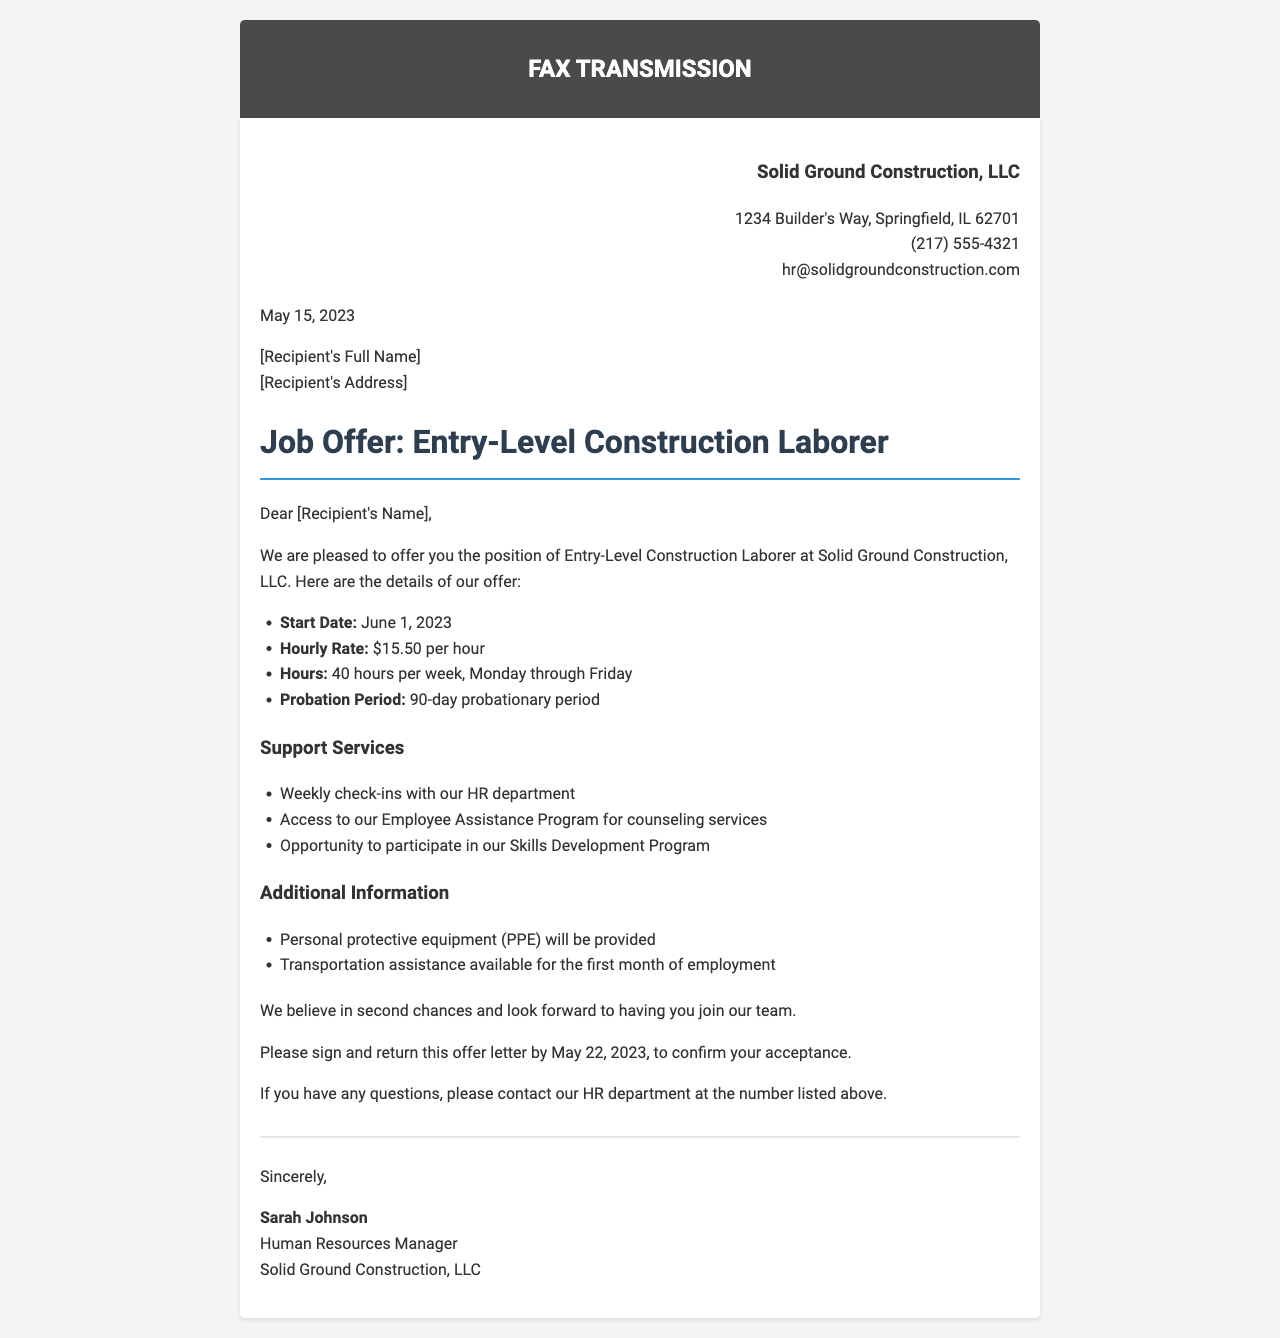What is the name of the company? The company is Solid Ground Construction, LLC, as stated in the document's header.
Answer: Solid Ground Construction, LLC What is the position offered? The job offer specifies the position as Entry-Level Construction Laborer.
Answer: Entry-Level Construction Laborer What is the hourly rate for the position? The document indicates the hourly rate to be $15.50 per hour.
Answer: $15.50 per hour When does the probation period end? The probationary period is stated to be 90 days, which concludes after the start date of June 1, 2023.
Answer: August 30, 2023 What support service offers weekly check-ins? The HR department will provide weekly check-ins as part of their support services.
Answer: HR department Is transportation assistance available? The document mentions that transportation assistance is available for the first month of employment.
Answer: Yes What is the deadline to return the offer letter? The letter specifies the deadline to return it as May 22, 2023.
Answer: May 22, 2023 Who is the Human Resources Manager? The signature section identifies Sarah Johnson as the Human Resources Manager.
Answer: Sarah Johnson 